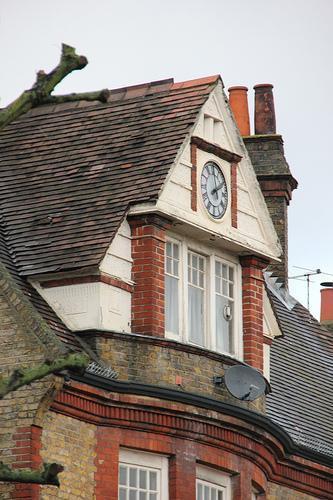How many satellite dishes are on the house?
Give a very brief answer. 1. How many hands are on the clock?
Give a very brief answer. 2. 